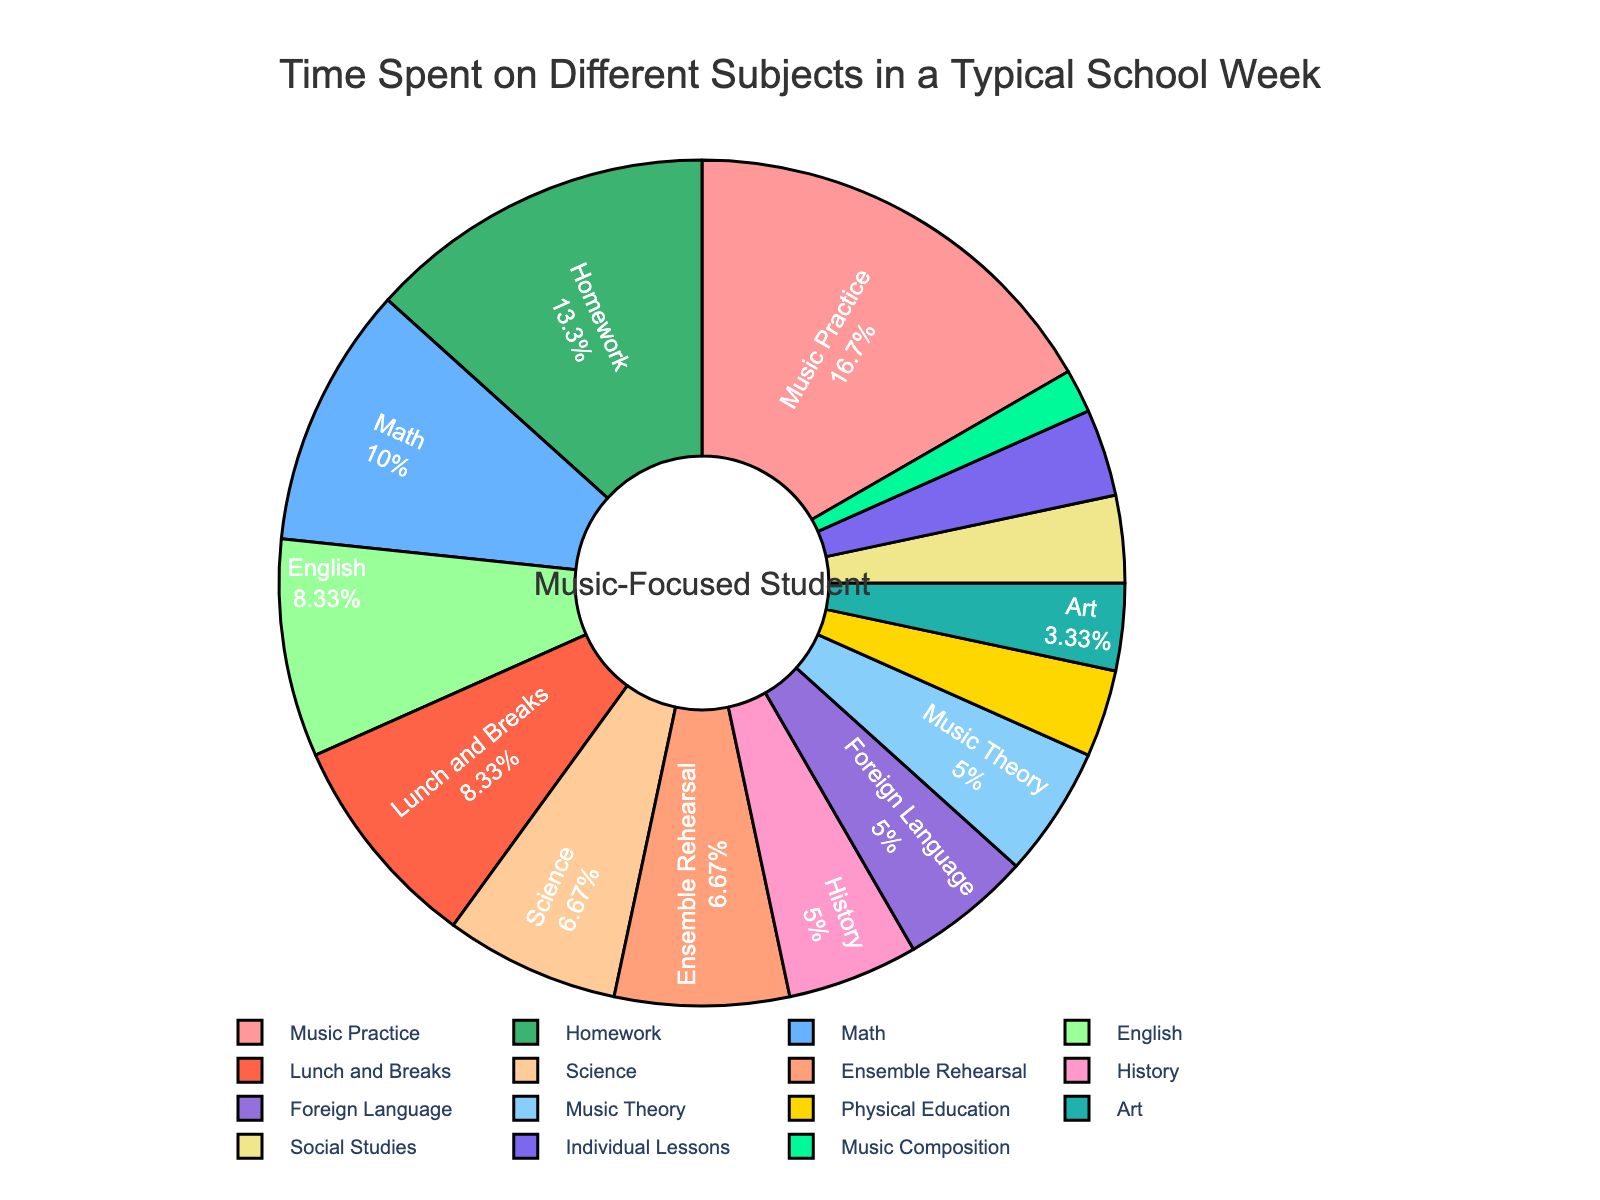what subject takes up the most time in a typical school week for a music-focused student? The pie chart shows the time spent on various subjects, and we see that "Music Practice" has the largest slice, indicating it takes up the most time.
Answer: Music Practice How much time is spent on music-related activities (total of Music Practice, Music Theory, Ensemble Rehearsal, Individual Lessons, and Music Composition)? Adding the hours for Music Practice (10), Music Theory (3), Ensemble Rehearsal (4), Individual Lessons (2), and Music Composition (1) gives a total of 20 hours.
Answer: 20 hours Which subject is given the least time, and how much time is spent on it? The smallest slice in the pie chart corresponds to "Music Composition," which is labeled with its percentage showing the smallest time allotment of 1 hour.
Answer: Music Composition, 1 hour How does the time spent on Math compare to the time spent on Science? From the pie chart, we can see that Math takes up more time (6 hours) compared to Science (4 hours), so Math takes 2 more hours than Science.
Answer: Math takes 2 more hours than Science Is the time spent on Physical Education more, less, or equal to the time spent on Art? Referring to the pie chart, Physical Education and Art each have a slice labeled with 2 hours, indicating that the time spent on them is equal.
Answer: Equal What is the total time dedicated to academic subjects excluding music-related ones (Math, English, Science, History, Physical Education, Foreign Language, Art, Lunch and Breaks, Homework, Social Studies)? Summing up the hours for non-music subjects: Math (6), English (5), Science (4), History (3), Physical Education (2), Foreign Language (3), Art (2), Lunch and Breaks (5), Homework (8), Social Studies (2), we get a total of 40 hours.
Answer: 40 hours Which has a larger proportion of time spent, History or Foreign Language, and by how much? According to the pie chart, History accounts for 3 hours while Foreign Language also accounts for 3 hours. Both subjects have the same time proportion.
Answer: Equal What visual characteristic helps identify the subject that takes the most time? The size of the slice in the pie chart visually indicates how much time is spent on each subject. The largest slice signifies the subject with the most time spent.
Answer: Largest slice What is the percent of time spent on Homework out of the total time shown? The pie chart labels each slice with a percentage. By referring to it directly, the percentage for Homework can be seen as a visual attribute.
Answer: Check the specific percentage on the pie chart Is more time spent on Math or on English and History combined? Math accounts for 6 hours. Combining English (5 hours) and History (3 hours) gives 8 hours. Therefore, more time is spent on English and History combined.
Answer: English and History combined 